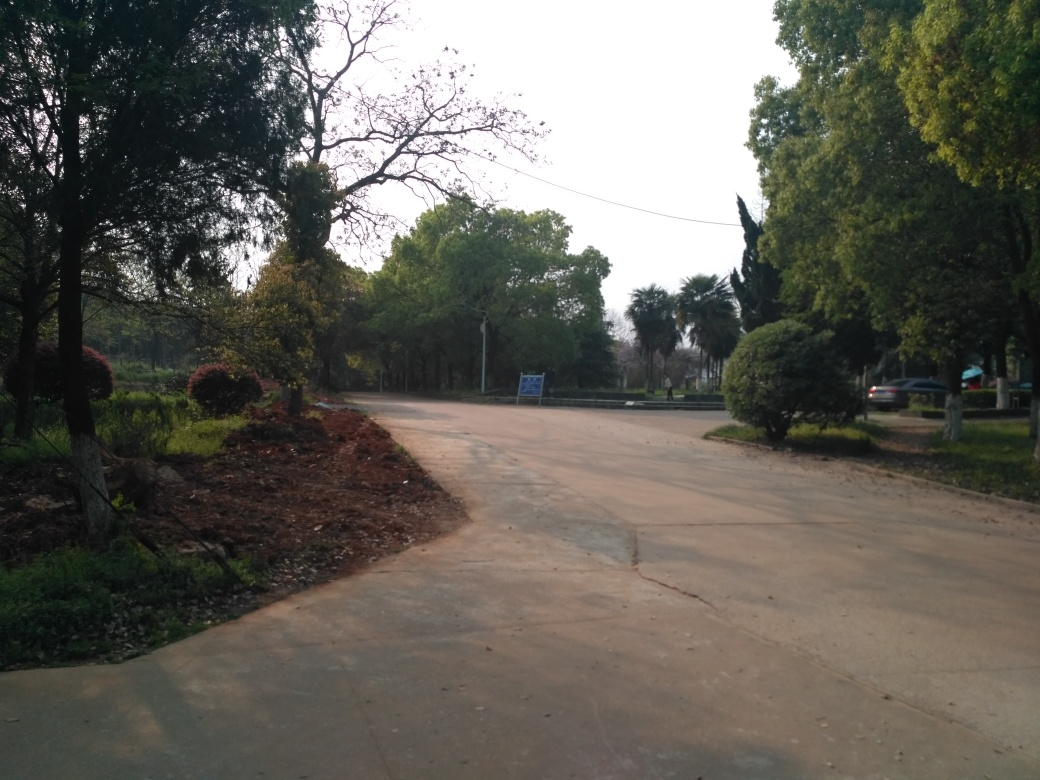Can you describe the weather conditions in the image? The weather conditions look fair with a clear or partly cloudy sky. There is sufficient daylight without signs of precipitation. The overall ambiance is that of a comfortable day suitable for outdoor activities. 